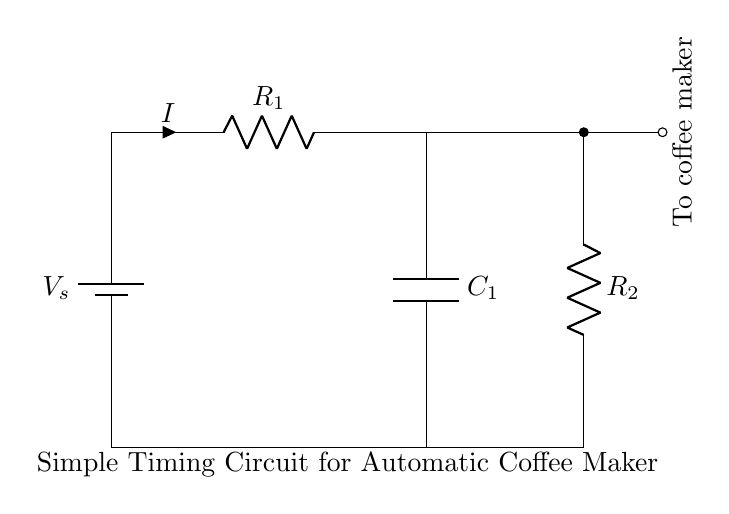What is the voltage source in this circuit? The voltage source is labeled as V_s, indicating it provides the necessary electrical potential for the circuit.
Answer: V_s What type of components are R1 and R2? Both R1 and R2 are resistors, as denoted by the symbol R in the circuit diagram.
Answer: Resistors What is the role of capacitor C1 in this circuit? C1 is a capacitor, which is used to store electrical energy temporarily and can influence the timing behavior of the circuit.
Answer: Store energy What is the current direction indicated in the circuit? The current direction is indicated by the arrow labeled I, which shows the flow from the voltage source through R1 and C1.
Answer: From V_s through R1 What is the function of the timing circuit? This timing circuit activates the coffee maker automatically based on timing provided by the capacitor's charging and discharging behavior.
Answer: Timing mechanism How many resistors are present in this circuit? There are two resistors present, labeled R1 and R2.
Answer: Two What does the arrow labeled "To coffee maker" indicate? The arrow indicates the output connection of this timing circuit, directing current to the coffee maker when activated.
Answer: Output to coffee maker 